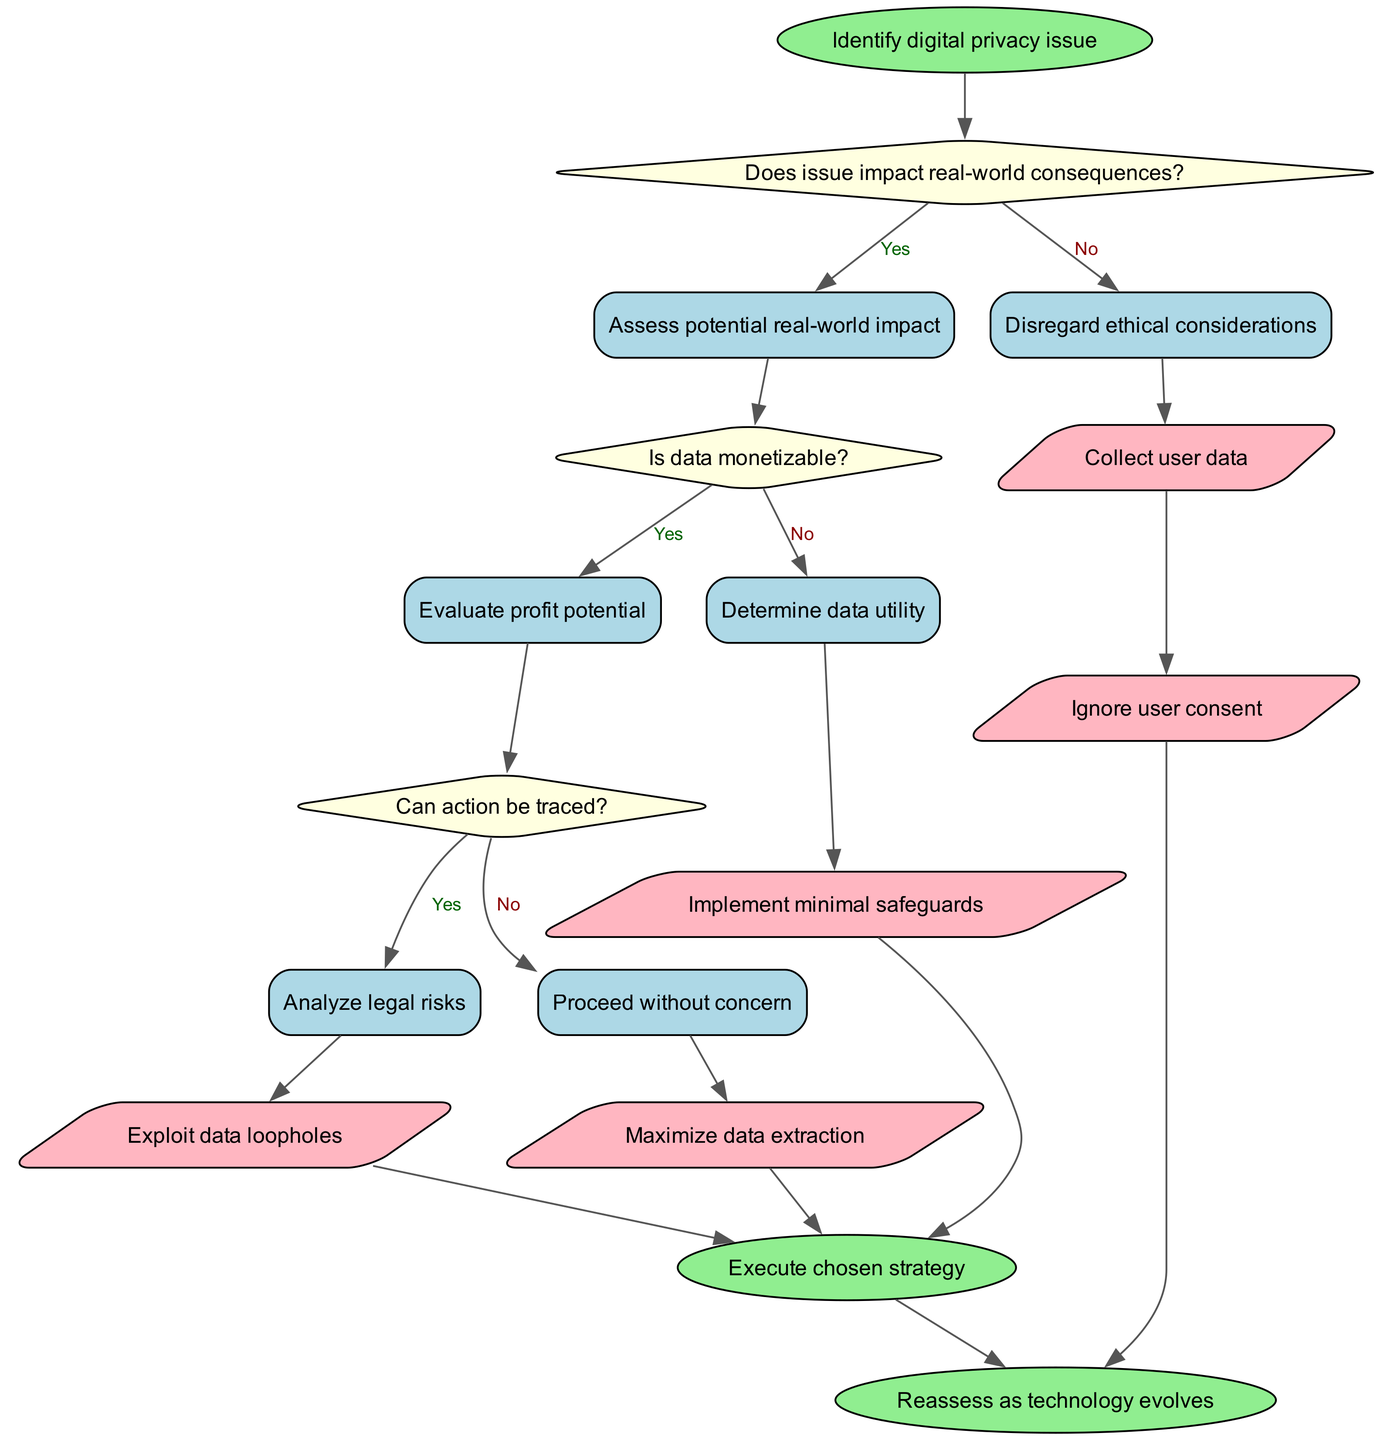How many decision nodes are in the diagram? The diagram contains three decision nodes, each representing a question regarding the digital privacy issue. These nodes are indicated in the structure as diamonds containing questions.
Answer: 3 What is the first action node after "Ignore user consent"? The action node after "Ignore user consent" is connected to "Execute chosen strategy," which indicates the final step taken after this action.
Answer: Execute chosen strategy Which question leads to assessing potential real-world impact? The question that leads to assessing potential real-world impact is the first decision: "Does issue impact real-world consequences?" The 'yes' branch of this decision directs towards that assessment.
Answer: Does issue impact real-world consequences? What happens if data is determined to be monetizable? If the data is assessed as monetizable, the next step is to evaluate the profit potential. This follows from the second decision regarding the monetizability of data.
Answer: Evaluate profit potential What are the possible end nodes in the diagram? The possible end nodes in the diagram are "Execute chosen strategy" and "Reassess as technology evolves", indicating either the execution of a strategy or future evaluation as technology changes.
Answer: Execute chosen strategy, Reassess as technology evolves What action is taken if the issue does not impact real-world consequences? If the issue does not impact real-world consequences, the flow proceeds to "Disregard ethical considerations," suggesting a dismissal of ethical aspects in this context.
Answer: Disregard ethical considerations If the data is not monetizable, what is the next consideration? If the data is determined not to be monetizable, the flow directs to "Determine data utility." This indicates an alternative evaluation path based on the utility of the data rather than its financial gain.
Answer: Determine data utility What leads to the final node "Reassess as technology evolves"? The final node "Reassess as technology evolves" is reached after following through the action of "Ignore user consent," implying that ongoing evolution in technology necessitates continuous reassessment.
Answer: Ignore user consent 